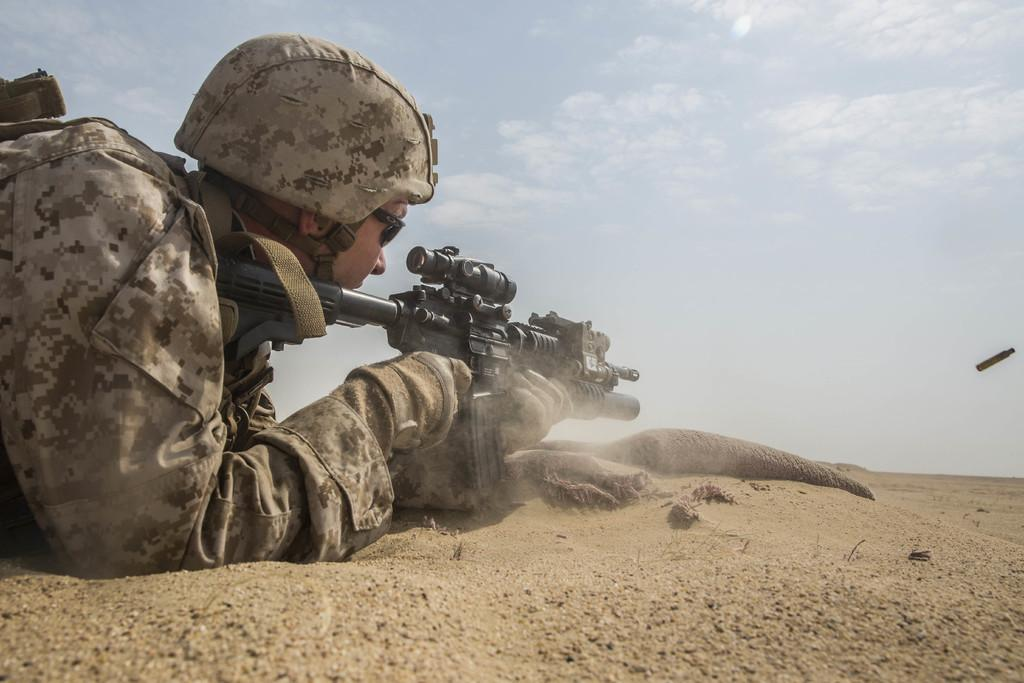What is the person in the image doing? The person is lying on the ground in the image. What object is the person holding? The person is holding a gun in the image. Is there any ammunition visible in the image? Yes, there is a bullet in the image. What can be seen in the background of the image? The sky is visible in the background of the image. What type of weather is suggested by the clouds in the sky? The presence of clouds in the sky suggests that it might be a partly cloudy day. How many toes can be seen on the person's foot in the image? There is no visible foot or toes in the image; the person is lying on the ground with their body mostly out of view. 